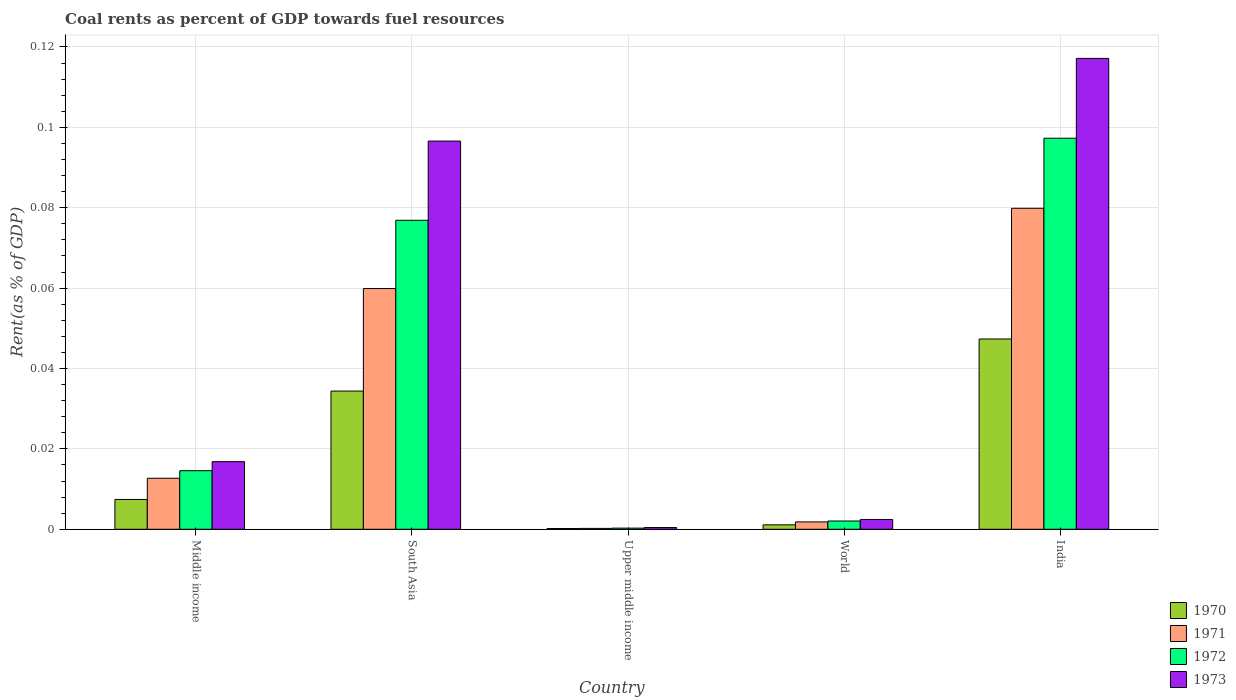Are the number of bars per tick equal to the number of legend labels?
Offer a terse response. Yes. Are the number of bars on each tick of the X-axis equal?
Your answer should be compact. Yes. How many bars are there on the 4th tick from the left?
Provide a succinct answer. 4. In how many cases, is the number of bars for a given country not equal to the number of legend labels?
Offer a terse response. 0. What is the coal rent in 1973 in Middle income?
Ensure brevity in your answer.  0.02. Across all countries, what is the maximum coal rent in 1971?
Give a very brief answer. 0.08. Across all countries, what is the minimum coal rent in 1973?
Offer a terse response. 0. In which country was the coal rent in 1970 minimum?
Your response must be concise. Upper middle income. What is the total coal rent in 1970 in the graph?
Offer a terse response. 0.09. What is the difference between the coal rent in 1970 in South Asia and that in World?
Provide a short and direct response. 0.03. What is the difference between the coal rent in 1971 in South Asia and the coal rent in 1973 in Middle income?
Provide a succinct answer. 0.04. What is the average coal rent in 1970 per country?
Offer a very short reply. 0.02. What is the difference between the coal rent of/in 1972 and coal rent of/in 1970 in South Asia?
Your answer should be very brief. 0.04. In how many countries, is the coal rent in 1972 greater than 0.032 %?
Ensure brevity in your answer.  2. What is the ratio of the coal rent in 1972 in India to that in World?
Your response must be concise. 47.35. Is the difference between the coal rent in 1972 in Upper middle income and World greater than the difference between the coal rent in 1970 in Upper middle income and World?
Provide a succinct answer. No. What is the difference between the highest and the second highest coal rent in 1973?
Make the answer very short. 0.02. What is the difference between the highest and the lowest coal rent in 1973?
Provide a short and direct response. 0.12. In how many countries, is the coal rent in 1973 greater than the average coal rent in 1973 taken over all countries?
Offer a terse response. 2. Is the sum of the coal rent in 1972 in Middle income and South Asia greater than the maximum coal rent in 1973 across all countries?
Keep it short and to the point. No. What does the 2nd bar from the left in Upper middle income represents?
Offer a very short reply. 1971. Is it the case that in every country, the sum of the coal rent in 1971 and coal rent in 1970 is greater than the coal rent in 1973?
Keep it short and to the point. No. How many bars are there?
Your answer should be compact. 20. Are all the bars in the graph horizontal?
Your response must be concise. No. How many countries are there in the graph?
Keep it short and to the point. 5. Does the graph contain any zero values?
Your response must be concise. No. Does the graph contain grids?
Your answer should be very brief. Yes. Where does the legend appear in the graph?
Provide a succinct answer. Bottom right. How many legend labels are there?
Make the answer very short. 4. What is the title of the graph?
Provide a succinct answer. Coal rents as percent of GDP towards fuel resources. Does "1968" appear as one of the legend labels in the graph?
Give a very brief answer. No. What is the label or title of the Y-axis?
Ensure brevity in your answer.  Rent(as % of GDP). What is the Rent(as % of GDP) in 1970 in Middle income?
Provide a succinct answer. 0.01. What is the Rent(as % of GDP) of 1971 in Middle income?
Ensure brevity in your answer.  0.01. What is the Rent(as % of GDP) of 1972 in Middle income?
Offer a very short reply. 0.01. What is the Rent(as % of GDP) of 1973 in Middle income?
Provide a short and direct response. 0.02. What is the Rent(as % of GDP) of 1970 in South Asia?
Provide a short and direct response. 0.03. What is the Rent(as % of GDP) in 1971 in South Asia?
Make the answer very short. 0.06. What is the Rent(as % of GDP) in 1972 in South Asia?
Offer a very short reply. 0.08. What is the Rent(as % of GDP) in 1973 in South Asia?
Your answer should be compact. 0.1. What is the Rent(as % of GDP) in 1970 in Upper middle income?
Make the answer very short. 0. What is the Rent(as % of GDP) in 1971 in Upper middle income?
Keep it short and to the point. 0. What is the Rent(as % of GDP) of 1972 in Upper middle income?
Your answer should be very brief. 0. What is the Rent(as % of GDP) of 1973 in Upper middle income?
Your answer should be compact. 0. What is the Rent(as % of GDP) of 1970 in World?
Your response must be concise. 0. What is the Rent(as % of GDP) in 1971 in World?
Your response must be concise. 0. What is the Rent(as % of GDP) of 1972 in World?
Give a very brief answer. 0. What is the Rent(as % of GDP) of 1973 in World?
Provide a succinct answer. 0. What is the Rent(as % of GDP) in 1970 in India?
Make the answer very short. 0.05. What is the Rent(as % of GDP) of 1971 in India?
Keep it short and to the point. 0.08. What is the Rent(as % of GDP) in 1972 in India?
Provide a succinct answer. 0.1. What is the Rent(as % of GDP) of 1973 in India?
Make the answer very short. 0.12. Across all countries, what is the maximum Rent(as % of GDP) in 1970?
Offer a very short reply. 0.05. Across all countries, what is the maximum Rent(as % of GDP) in 1971?
Ensure brevity in your answer.  0.08. Across all countries, what is the maximum Rent(as % of GDP) of 1972?
Your answer should be very brief. 0.1. Across all countries, what is the maximum Rent(as % of GDP) of 1973?
Offer a terse response. 0.12. Across all countries, what is the minimum Rent(as % of GDP) of 1970?
Your response must be concise. 0. Across all countries, what is the minimum Rent(as % of GDP) in 1971?
Your response must be concise. 0. Across all countries, what is the minimum Rent(as % of GDP) of 1972?
Provide a short and direct response. 0. Across all countries, what is the minimum Rent(as % of GDP) of 1973?
Offer a terse response. 0. What is the total Rent(as % of GDP) in 1970 in the graph?
Your response must be concise. 0.09. What is the total Rent(as % of GDP) in 1971 in the graph?
Your answer should be very brief. 0.15. What is the total Rent(as % of GDP) in 1972 in the graph?
Your response must be concise. 0.19. What is the total Rent(as % of GDP) of 1973 in the graph?
Offer a terse response. 0.23. What is the difference between the Rent(as % of GDP) of 1970 in Middle income and that in South Asia?
Keep it short and to the point. -0.03. What is the difference between the Rent(as % of GDP) in 1971 in Middle income and that in South Asia?
Your answer should be compact. -0.05. What is the difference between the Rent(as % of GDP) of 1972 in Middle income and that in South Asia?
Offer a terse response. -0.06. What is the difference between the Rent(as % of GDP) in 1973 in Middle income and that in South Asia?
Offer a very short reply. -0.08. What is the difference between the Rent(as % of GDP) in 1970 in Middle income and that in Upper middle income?
Make the answer very short. 0.01. What is the difference between the Rent(as % of GDP) in 1971 in Middle income and that in Upper middle income?
Your response must be concise. 0.01. What is the difference between the Rent(as % of GDP) in 1972 in Middle income and that in Upper middle income?
Keep it short and to the point. 0.01. What is the difference between the Rent(as % of GDP) of 1973 in Middle income and that in Upper middle income?
Your response must be concise. 0.02. What is the difference between the Rent(as % of GDP) in 1970 in Middle income and that in World?
Offer a very short reply. 0.01. What is the difference between the Rent(as % of GDP) of 1971 in Middle income and that in World?
Provide a succinct answer. 0.01. What is the difference between the Rent(as % of GDP) of 1972 in Middle income and that in World?
Offer a terse response. 0.01. What is the difference between the Rent(as % of GDP) in 1973 in Middle income and that in World?
Your answer should be compact. 0.01. What is the difference between the Rent(as % of GDP) of 1970 in Middle income and that in India?
Ensure brevity in your answer.  -0.04. What is the difference between the Rent(as % of GDP) in 1971 in Middle income and that in India?
Provide a succinct answer. -0.07. What is the difference between the Rent(as % of GDP) in 1972 in Middle income and that in India?
Your answer should be compact. -0.08. What is the difference between the Rent(as % of GDP) in 1973 in Middle income and that in India?
Give a very brief answer. -0.1. What is the difference between the Rent(as % of GDP) in 1970 in South Asia and that in Upper middle income?
Your answer should be very brief. 0.03. What is the difference between the Rent(as % of GDP) in 1971 in South Asia and that in Upper middle income?
Offer a very short reply. 0.06. What is the difference between the Rent(as % of GDP) in 1972 in South Asia and that in Upper middle income?
Your answer should be very brief. 0.08. What is the difference between the Rent(as % of GDP) of 1973 in South Asia and that in Upper middle income?
Give a very brief answer. 0.1. What is the difference between the Rent(as % of GDP) of 1970 in South Asia and that in World?
Your answer should be very brief. 0.03. What is the difference between the Rent(as % of GDP) of 1971 in South Asia and that in World?
Give a very brief answer. 0.06. What is the difference between the Rent(as % of GDP) of 1972 in South Asia and that in World?
Your response must be concise. 0.07. What is the difference between the Rent(as % of GDP) of 1973 in South Asia and that in World?
Provide a succinct answer. 0.09. What is the difference between the Rent(as % of GDP) in 1970 in South Asia and that in India?
Offer a terse response. -0.01. What is the difference between the Rent(as % of GDP) of 1971 in South Asia and that in India?
Make the answer very short. -0.02. What is the difference between the Rent(as % of GDP) of 1972 in South Asia and that in India?
Offer a very short reply. -0.02. What is the difference between the Rent(as % of GDP) in 1973 in South Asia and that in India?
Your answer should be compact. -0.02. What is the difference between the Rent(as % of GDP) in 1970 in Upper middle income and that in World?
Provide a short and direct response. -0. What is the difference between the Rent(as % of GDP) of 1971 in Upper middle income and that in World?
Give a very brief answer. -0. What is the difference between the Rent(as % of GDP) of 1972 in Upper middle income and that in World?
Make the answer very short. -0. What is the difference between the Rent(as % of GDP) of 1973 in Upper middle income and that in World?
Offer a terse response. -0. What is the difference between the Rent(as % of GDP) in 1970 in Upper middle income and that in India?
Offer a terse response. -0.05. What is the difference between the Rent(as % of GDP) of 1971 in Upper middle income and that in India?
Offer a very short reply. -0.08. What is the difference between the Rent(as % of GDP) of 1972 in Upper middle income and that in India?
Ensure brevity in your answer.  -0.1. What is the difference between the Rent(as % of GDP) in 1973 in Upper middle income and that in India?
Ensure brevity in your answer.  -0.12. What is the difference between the Rent(as % of GDP) of 1970 in World and that in India?
Your answer should be compact. -0.05. What is the difference between the Rent(as % of GDP) of 1971 in World and that in India?
Your answer should be compact. -0.08. What is the difference between the Rent(as % of GDP) in 1972 in World and that in India?
Provide a short and direct response. -0.1. What is the difference between the Rent(as % of GDP) in 1973 in World and that in India?
Offer a terse response. -0.11. What is the difference between the Rent(as % of GDP) in 1970 in Middle income and the Rent(as % of GDP) in 1971 in South Asia?
Your answer should be very brief. -0.05. What is the difference between the Rent(as % of GDP) of 1970 in Middle income and the Rent(as % of GDP) of 1972 in South Asia?
Ensure brevity in your answer.  -0.07. What is the difference between the Rent(as % of GDP) in 1970 in Middle income and the Rent(as % of GDP) in 1973 in South Asia?
Offer a very short reply. -0.09. What is the difference between the Rent(as % of GDP) of 1971 in Middle income and the Rent(as % of GDP) of 1972 in South Asia?
Provide a short and direct response. -0.06. What is the difference between the Rent(as % of GDP) in 1971 in Middle income and the Rent(as % of GDP) in 1973 in South Asia?
Give a very brief answer. -0.08. What is the difference between the Rent(as % of GDP) of 1972 in Middle income and the Rent(as % of GDP) of 1973 in South Asia?
Provide a short and direct response. -0.08. What is the difference between the Rent(as % of GDP) in 1970 in Middle income and the Rent(as % of GDP) in 1971 in Upper middle income?
Provide a succinct answer. 0.01. What is the difference between the Rent(as % of GDP) in 1970 in Middle income and the Rent(as % of GDP) in 1972 in Upper middle income?
Offer a very short reply. 0.01. What is the difference between the Rent(as % of GDP) in 1970 in Middle income and the Rent(as % of GDP) in 1973 in Upper middle income?
Your response must be concise. 0.01. What is the difference between the Rent(as % of GDP) in 1971 in Middle income and the Rent(as % of GDP) in 1972 in Upper middle income?
Your response must be concise. 0.01. What is the difference between the Rent(as % of GDP) in 1971 in Middle income and the Rent(as % of GDP) in 1973 in Upper middle income?
Provide a short and direct response. 0.01. What is the difference between the Rent(as % of GDP) in 1972 in Middle income and the Rent(as % of GDP) in 1973 in Upper middle income?
Give a very brief answer. 0.01. What is the difference between the Rent(as % of GDP) in 1970 in Middle income and the Rent(as % of GDP) in 1971 in World?
Make the answer very short. 0.01. What is the difference between the Rent(as % of GDP) of 1970 in Middle income and the Rent(as % of GDP) of 1972 in World?
Ensure brevity in your answer.  0.01. What is the difference between the Rent(as % of GDP) of 1970 in Middle income and the Rent(as % of GDP) of 1973 in World?
Give a very brief answer. 0.01. What is the difference between the Rent(as % of GDP) in 1971 in Middle income and the Rent(as % of GDP) in 1972 in World?
Offer a terse response. 0.01. What is the difference between the Rent(as % of GDP) of 1971 in Middle income and the Rent(as % of GDP) of 1973 in World?
Offer a terse response. 0.01. What is the difference between the Rent(as % of GDP) in 1972 in Middle income and the Rent(as % of GDP) in 1973 in World?
Make the answer very short. 0.01. What is the difference between the Rent(as % of GDP) in 1970 in Middle income and the Rent(as % of GDP) in 1971 in India?
Give a very brief answer. -0.07. What is the difference between the Rent(as % of GDP) of 1970 in Middle income and the Rent(as % of GDP) of 1972 in India?
Your response must be concise. -0.09. What is the difference between the Rent(as % of GDP) in 1970 in Middle income and the Rent(as % of GDP) in 1973 in India?
Your answer should be compact. -0.11. What is the difference between the Rent(as % of GDP) in 1971 in Middle income and the Rent(as % of GDP) in 1972 in India?
Provide a succinct answer. -0.08. What is the difference between the Rent(as % of GDP) in 1971 in Middle income and the Rent(as % of GDP) in 1973 in India?
Keep it short and to the point. -0.1. What is the difference between the Rent(as % of GDP) in 1972 in Middle income and the Rent(as % of GDP) in 1973 in India?
Offer a very short reply. -0.1. What is the difference between the Rent(as % of GDP) of 1970 in South Asia and the Rent(as % of GDP) of 1971 in Upper middle income?
Provide a short and direct response. 0.03. What is the difference between the Rent(as % of GDP) of 1970 in South Asia and the Rent(as % of GDP) of 1972 in Upper middle income?
Your response must be concise. 0.03. What is the difference between the Rent(as % of GDP) in 1970 in South Asia and the Rent(as % of GDP) in 1973 in Upper middle income?
Make the answer very short. 0.03. What is the difference between the Rent(as % of GDP) of 1971 in South Asia and the Rent(as % of GDP) of 1972 in Upper middle income?
Offer a terse response. 0.06. What is the difference between the Rent(as % of GDP) in 1971 in South Asia and the Rent(as % of GDP) in 1973 in Upper middle income?
Your response must be concise. 0.06. What is the difference between the Rent(as % of GDP) in 1972 in South Asia and the Rent(as % of GDP) in 1973 in Upper middle income?
Offer a terse response. 0.08. What is the difference between the Rent(as % of GDP) of 1970 in South Asia and the Rent(as % of GDP) of 1971 in World?
Provide a succinct answer. 0.03. What is the difference between the Rent(as % of GDP) of 1970 in South Asia and the Rent(as % of GDP) of 1972 in World?
Ensure brevity in your answer.  0.03. What is the difference between the Rent(as % of GDP) in 1970 in South Asia and the Rent(as % of GDP) in 1973 in World?
Provide a succinct answer. 0.03. What is the difference between the Rent(as % of GDP) of 1971 in South Asia and the Rent(as % of GDP) of 1972 in World?
Your answer should be very brief. 0.06. What is the difference between the Rent(as % of GDP) of 1971 in South Asia and the Rent(as % of GDP) of 1973 in World?
Your response must be concise. 0.06. What is the difference between the Rent(as % of GDP) in 1972 in South Asia and the Rent(as % of GDP) in 1973 in World?
Provide a succinct answer. 0.07. What is the difference between the Rent(as % of GDP) of 1970 in South Asia and the Rent(as % of GDP) of 1971 in India?
Ensure brevity in your answer.  -0.05. What is the difference between the Rent(as % of GDP) of 1970 in South Asia and the Rent(as % of GDP) of 1972 in India?
Make the answer very short. -0.06. What is the difference between the Rent(as % of GDP) in 1970 in South Asia and the Rent(as % of GDP) in 1973 in India?
Your answer should be compact. -0.08. What is the difference between the Rent(as % of GDP) in 1971 in South Asia and the Rent(as % of GDP) in 1972 in India?
Keep it short and to the point. -0.04. What is the difference between the Rent(as % of GDP) in 1971 in South Asia and the Rent(as % of GDP) in 1973 in India?
Your response must be concise. -0.06. What is the difference between the Rent(as % of GDP) in 1972 in South Asia and the Rent(as % of GDP) in 1973 in India?
Provide a succinct answer. -0.04. What is the difference between the Rent(as % of GDP) in 1970 in Upper middle income and the Rent(as % of GDP) in 1971 in World?
Your answer should be compact. -0. What is the difference between the Rent(as % of GDP) in 1970 in Upper middle income and the Rent(as % of GDP) in 1972 in World?
Provide a succinct answer. -0. What is the difference between the Rent(as % of GDP) of 1970 in Upper middle income and the Rent(as % of GDP) of 1973 in World?
Make the answer very short. -0. What is the difference between the Rent(as % of GDP) in 1971 in Upper middle income and the Rent(as % of GDP) in 1972 in World?
Your response must be concise. -0. What is the difference between the Rent(as % of GDP) of 1971 in Upper middle income and the Rent(as % of GDP) of 1973 in World?
Keep it short and to the point. -0. What is the difference between the Rent(as % of GDP) in 1972 in Upper middle income and the Rent(as % of GDP) in 1973 in World?
Make the answer very short. -0. What is the difference between the Rent(as % of GDP) in 1970 in Upper middle income and the Rent(as % of GDP) in 1971 in India?
Provide a succinct answer. -0.08. What is the difference between the Rent(as % of GDP) in 1970 in Upper middle income and the Rent(as % of GDP) in 1972 in India?
Provide a short and direct response. -0.1. What is the difference between the Rent(as % of GDP) in 1970 in Upper middle income and the Rent(as % of GDP) in 1973 in India?
Your answer should be very brief. -0.12. What is the difference between the Rent(as % of GDP) of 1971 in Upper middle income and the Rent(as % of GDP) of 1972 in India?
Offer a very short reply. -0.1. What is the difference between the Rent(as % of GDP) in 1971 in Upper middle income and the Rent(as % of GDP) in 1973 in India?
Keep it short and to the point. -0.12. What is the difference between the Rent(as % of GDP) of 1972 in Upper middle income and the Rent(as % of GDP) of 1973 in India?
Your response must be concise. -0.12. What is the difference between the Rent(as % of GDP) of 1970 in World and the Rent(as % of GDP) of 1971 in India?
Ensure brevity in your answer.  -0.08. What is the difference between the Rent(as % of GDP) in 1970 in World and the Rent(as % of GDP) in 1972 in India?
Your answer should be very brief. -0.1. What is the difference between the Rent(as % of GDP) in 1970 in World and the Rent(as % of GDP) in 1973 in India?
Your answer should be very brief. -0.12. What is the difference between the Rent(as % of GDP) of 1971 in World and the Rent(as % of GDP) of 1972 in India?
Offer a very short reply. -0.1. What is the difference between the Rent(as % of GDP) in 1971 in World and the Rent(as % of GDP) in 1973 in India?
Give a very brief answer. -0.12. What is the difference between the Rent(as % of GDP) of 1972 in World and the Rent(as % of GDP) of 1973 in India?
Ensure brevity in your answer.  -0.12. What is the average Rent(as % of GDP) in 1970 per country?
Keep it short and to the point. 0.02. What is the average Rent(as % of GDP) of 1971 per country?
Provide a short and direct response. 0.03. What is the average Rent(as % of GDP) in 1972 per country?
Offer a terse response. 0.04. What is the average Rent(as % of GDP) of 1973 per country?
Provide a short and direct response. 0.05. What is the difference between the Rent(as % of GDP) in 1970 and Rent(as % of GDP) in 1971 in Middle income?
Give a very brief answer. -0.01. What is the difference between the Rent(as % of GDP) in 1970 and Rent(as % of GDP) in 1972 in Middle income?
Your answer should be compact. -0.01. What is the difference between the Rent(as % of GDP) in 1970 and Rent(as % of GDP) in 1973 in Middle income?
Keep it short and to the point. -0.01. What is the difference between the Rent(as % of GDP) of 1971 and Rent(as % of GDP) of 1972 in Middle income?
Make the answer very short. -0. What is the difference between the Rent(as % of GDP) of 1971 and Rent(as % of GDP) of 1973 in Middle income?
Offer a very short reply. -0. What is the difference between the Rent(as % of GDP) in 1972 and Rent(as % of GDP) in 1973 in Middle income?
Make the answer very short. -0. What is the difference between the Rent(as % of GDP) in 1970 and Rent(as % of GDP) in 1971 in South Asia?
Ensure brevity in your answer.  -0.03. What is the difference between the Rent(as % of GDP) of 1970 and Rent(as % of GDP) of 1972 in South Asia?
Make the answer very short. -0.04. What is the difference between the Rent(as % of GDP) in 1970 and Rent(as % of GDP) in 1973 in South Asia?
Your answer should be very brief. -0.06. What is the difference between the Rent(as % of GDP) in 1971 and Rent(as % of GDP) in 1972 in South Asia?
Ensure brevity in your answer.  -0.02. What is the difference between the Rent(as % of GDP) of 1971 and Rent(as % of GDP) of 1973 in South Asia?
Your answer should be very brief. -0.04. What is the difference between the Rent(as % of GDP) in 1972 and Rent(as % of GDP) in 1973 in South Asia?
Your response must be concise. -0.02. What is the difference between the Rent(as % of GDP) of 1970 and Rent(as % of GDP) of 1972 in Upper middle income?
Give a very brief answer. -0. What is the difference between the Rent(as % of GDP) in 1970 and Rent(as % of GDP) in 1973 in Upper middle income?
Give a very brief answer. -0. What is the difference between the Rent(as % of GDP) of 1971 and Rent(as % of GDP) of 1972 in Upper middle income?
Give a very brief answer. -0. What is the difference between the Rent(as % of GDP) in 1971 and Rent(as % of GDP) in 1973 in Upper middle income?
Provide a succinct answer. -0. What is the difference between the Rent(as % of GDP) of 1972 and Rent(as % of GDP) of 1973 in Upper middle income?
Your response must be concise. -0. What is the difference between the Rent(as % of GDP) of 1970 and Rent(as % of GDP) of 1971 in World?
Give a very brief answer. -0. What is the difference between the Rent(as % of GDP) in 1970 and Rent(as % of GDP) in 1972 in World?
Your answer should be very brief. -0. What is the difference between the Rent(as % of GDP) in 1970 and Rent(as % of GDP) in 1973 in World?
Your answer should be compact. -0. What is the difference between the Rent(as % of GDP) in 1971 and Rent(as % of GDP) in 1972 in World?
Offer a very short reply. -0. What is the difference between the Rent(as % of GDP) in 1971 and Rent(as % of GDP) in 1973 in World?
Give a very brief answer. -0. What is the difference between the Rent(as % of GDP) of 1972 and Rent(as % of GDP) of 1973 in World?
Offer a very short reply. -0. What is the difference between the Rent(as % of GDP) of 1970 and Rent(as % of GDP) of 1971 in India?
Provide a short and direct response. -0.03. What is the difference between the Rent(as % of GDP) of 1970 and Rent(as % of GDP) of 1973 in India?
Your answer should be very brief. -0.07. What is the difference between the Rent(as % of GDP) in 1971 and Rent(as % of GDP) in 1972 in India?
Provide a short and direct response. -0.02. What is the difference between the Rent(as % of GDP) of 1971 and Rent(as % of GDP) of 1973 in India?
Offer a very short reply. -0.04. What is the difference between the Rent(as % of GDP) of 1972 and Rent(as % of GDP) of 1973 in India?
Provide a succinct answer. -0.02. What is the ratio of the Rent(as % of GDP) in 1970 in Middle income to that in South Asia?
Keep it short and to the point. 0.22. What is the ratio of the Rent(as % of GDP) in 1971 in Middle income to that in South Asia?
Provide a succinct answer. 0.21. What is the ratio of the Rent(as % of GDP) in 1972 in Middle income to that in South Asia?
Your answer should be compact. 0.19. What is the ratio of the Rent(as % of GDP) in 1973 in Middle income to that in South Asia?
Your answer should be very brief. 0.17. What is the ratio of the Rent(as % of GDP) in 1970 in Middle income to that in Upper middle income?
Provide a short and direct response. 40.36. What is the ratio of the Rent(as % of GDP) of 1971 in Middle income to that in Upper middle income?
Keep it short and to the point. 58.01. What is the ratio of the Rent(as % of GDP) in 1972 in Middle income to that in Upper middle income?
Make the answer very short. 51.25. What is the ratio of the Rent(as % of GDP) of 1973 in Middle income to that in Upper middle income?
Offer a very short reply. 39.04. What is the ratio of the Rent(as % of GDP) of 1970 in Middle income to that in World?
Offer a very short reply. 6.74. What is the ratio of the Rent(as % of GDP) in 1971 in Middle income to that in World?
Offer a terse response. 6.93. What is the ratio of the Rent(as % of GDP) in 1972 in Middle income to that in World?
Your answer should be compact. 7.09. What is the ratio of the Rent(as % of GDP) of 1973 in Middle income to that in World?
Make the answer very short. 6.91. What is the ratio of the Rent(as % of GDP) in 1970 in Middle income to that in India?
Your answer should be very brief. 0.16. What is the ratio of the Rent(as % of GDP) of 1971 in Middle income to that in India?
Your response must be concise. 0.16. What is the ratio of the Rent(as % of GDP) in 1972 in Middle income to that in India?
Your response must be concise. 0.15. What is the ratio of the Rent(as % of GDP) in 1973 in Middle income to that in India?
Your answer should be compact. 0.14. What is the ratio of the Rent(as % of GDP) of 1970 in South Asia to that in Upper middle income?
Keep it short and to the point. 187.05. What is the ratio of the Rent(as % of GDP) in 1971 in South Asia to that in Upper middle income?
Offer a very short reply. 273.74. What is the ratio of the Rent(as % of GDP) in 1972 in South Asia to that in Upper middle income?
Your answer should be compact. 270.32. What is the ratio of the Rent(as % of GDP) in 1973 in South Asia to that in Upper middle income?
Ensure brevity in your answer.  224.18. What is the ratio of the Rent(as % of GDP) in 1970 in South Asia to that in World?
Ensure brevity in your answer.  31.24. What is the ratio of the Rent(as % of GDP) of 1971 in South Asia to that in World?
Your response must be concise. 32.69. What is the ratio of the Rent(as % of GDP) in 1972 in South Asia to that in World?
Give a very brief answer. 37.41. What is the ratio of the Rent(as % of GDP) in 1973 in South Asia to that in World?
Give a very brief answer. 39.65. What is the ratio of the Rent(as % of GDP) of 1970 in South Asia to that in India?
Your answer should be compact. 0.73. What is the ratio of the Rent(as % of GDP) in 1971 in South Asia to that in India?
Your response must be concise. 0.75. What is the ratio of the Rent(as % of GDP) of 1972 in South Asia to that in India?
Offer a terse response. 0.79. What is the ratio of the Rent(as % of GDP) of 1973 in South Asia to that in India?
Make the answer very short. 0.82. What is the ratio of the Rent(as % of GDP) in 1970 in Upper middle income to that in World?
Offer a terse response. 0.17. What is the ratio of the Rent(as % of GDP) of 1971 in Upper middle income to that in World?
Provide a succinct answer. 0.12. What is the ratio of the Rent(as % of GDP) of 1972 in Upper middle income to that in World?
Provide a succinct answer. 0.14. What is the ratio of the Rent(as % of GDP) of 1973 in Upper middle income to that in World?
Offer a very short reply. 0.18. What is the ratio of the Rent(as % of GDP) in 1970 in Upper middle income to that in India?
Offer a very short reply. 0. What is the ratio of the Rent(as % of GDP) in 1971 in Upper middle income to that in India?
Make the answer very short. 0. What is the ratio of the Rent(as % of GDP) in 1972 in Upper middle income to that in India?
Ensure brevity in your answer.  0. What is the ratio of the Rent(as % of GDP) of 1973 in Upper middle income to that in India?
Ensure brevity in your answer.  0. What is the ratio of the Rent(as % of GDP) in 1970 in World to that in India?
Give a very brief answer. 0.02. What is the ratio of the Rent(as % of GDP) in 1971 in World to that in India?
Offer a very short reply. 0.02. What is the ratio of the Rent(as % of GDP) in 1972 in World to that in India?
Keep it short and to the point. 0.02. What is the ratio of the Rent(as % of GDP) in 1973 in World to that in India?
Provide a succinct answer. 0.02. What is the difference between the highest and the second highest Rent(as % of GDP) in 1970?
Provide a short and direct response. 0.01. What is the difference between the highest and the second highest Rent(as % of GDP) in 1971?
Offer a terse response. 0.02. What is the difference between the highest and the second highest Rent(as % of GDP) in 1972?
Give a very brief answer. 0.02. What is the difference between the highest and the second highest Rent(as % of GDP) of 1973?
Keep it short and to the point. 0.02. What is the difference between the highest and the lowest Rent(as % of GDP) in 1970?
Keep it short and to the point. 0.05. What is the difference between the highest and the lowest Rent(as % of GDP) in 1971?
Keep it short and to the point. 0.08. What is the difference between the highest and the lowest Rent(as % of GDP) of 1972?
Ensure brevity in your answer.  0.1. What is the difference between the highest and the lowest Rent(as % of GDP) in 1973?
Give a very brief answer. 0.12. 